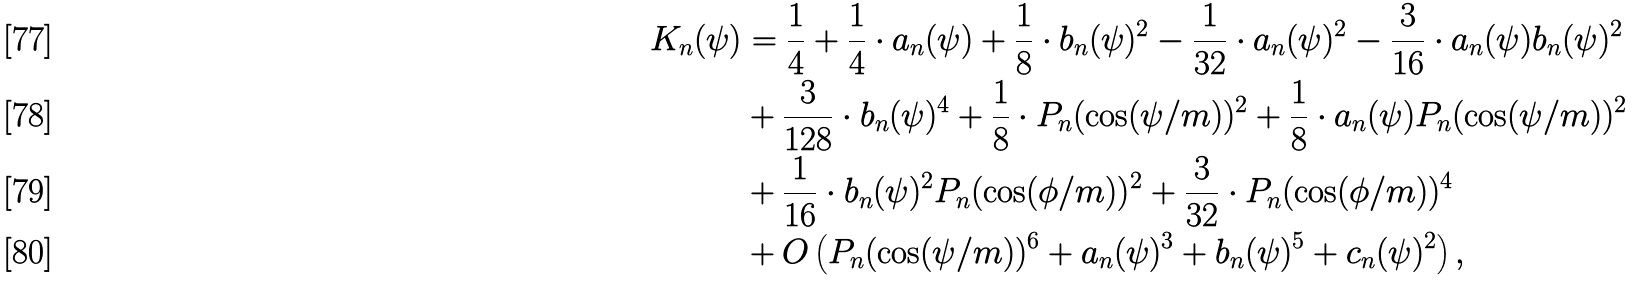Convert formula to latex. <formula><loc_0><loc_0><loc_500><loc_500>K _ { n } ( \psi ) & = \frac { 1 } { 4 } + \frac { 1 } { 4 } \cdot a _ { n } ( \psi ) + \frac { 1 } { 8 } \cdot b _ { n } ( \psi ) ^ { 2 } - \frac { 1 } { 3 2 } \cdot a _ { n } ( \psi ) ^ { 2 } - \frac { 3 } { 1 6 } \cdot a _ { n } ( \psi ) b _ { n } ( \psi ) ^ { 2 } \\ & + \frac { 3 } { 1 2 8 } \cdot b _ { n } ( \psi ) ^ { 4 } + \frac { 1 } { 8 } \cdot P _ { n } ( \cos ( \psi / m ) ) ^ { 2 } + \frac { 1 } { 8 } \cdot a _ { n } ( \psi ) P _ { n } ( \cos ( \psi / m ) ) ^ { 2 } \\ & + \frac { 1 } { 1 6 } \cdot b _ { n } ( \psi ) ^ { 2 } P _ { n } ( \cos ( \phi / m ) ) ^ { 2 } + \frac { 3 } { 3 2 } \cdot P _ { n } ( \cos ( \phi / m ) ) ^ { 4 } \\ & + O \left ( P _ { n } ( \cos ( \psi / m ) ) ^ { 6 } + a _ { n } ( \psi ) ^ { 3 } + b _ { n } ( \psi ) ^ { 5 } + c _ { n } ( \psi ) ^ { 2 } \right ) ,</formula> 